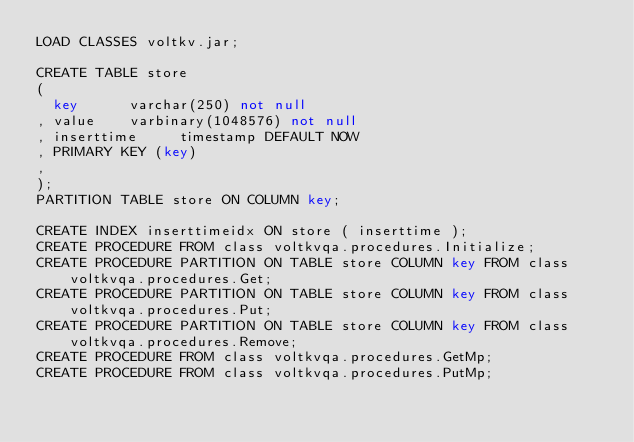<code> <loc_0><loc_0><loc_500><loc_500><_SQL_>LOAD CLASSES voltkv.jar;

CREATE TABLE store
(
  key      varchar(250) not null
, value    varbinary(1048576) not null
, inserttime     timestamp DEFAULT NOW
, PRIMARY KEY (key)
,
);
PARTITION TABLE store ON COLUMN key;

CREATE INDEX inserttimeidx ON store ( inserttime );
CREATE PROCEDURE FROM class voltkvqa.procedures.Initialize;
CREATE PROCEDURE PARTITION ON TABLE store COLUMN key FROM class voltkvqa.procedures.Get;
CREATE PROCEDURE PARTITION ON TABLE store COLUMN key FROM class voltkvqa.procedures.Put;
CREATE PROCEDURE PARTITION ON TABLE store COLUMN key FROM class voltkvqa.procedures.Remove;
CREATE PROCEDURE FROM class voltkvqa.procedures.GetMp;
CREATE PROCEDURE FROM class voltkvqa.procedures.PutMp;

</code> 